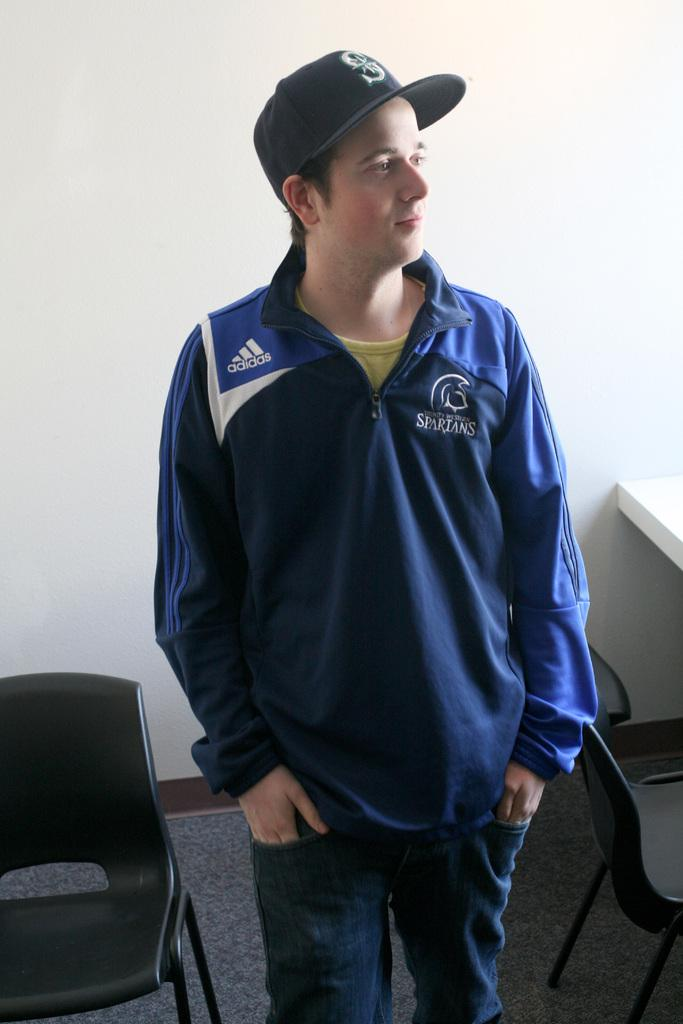<image>
Describe the image concisely. a man standing with a jacket from the spartans 